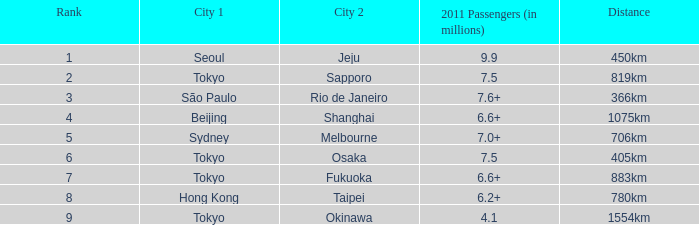Which city is listed first when Okinawa is listed as the second city? Tokyo. 